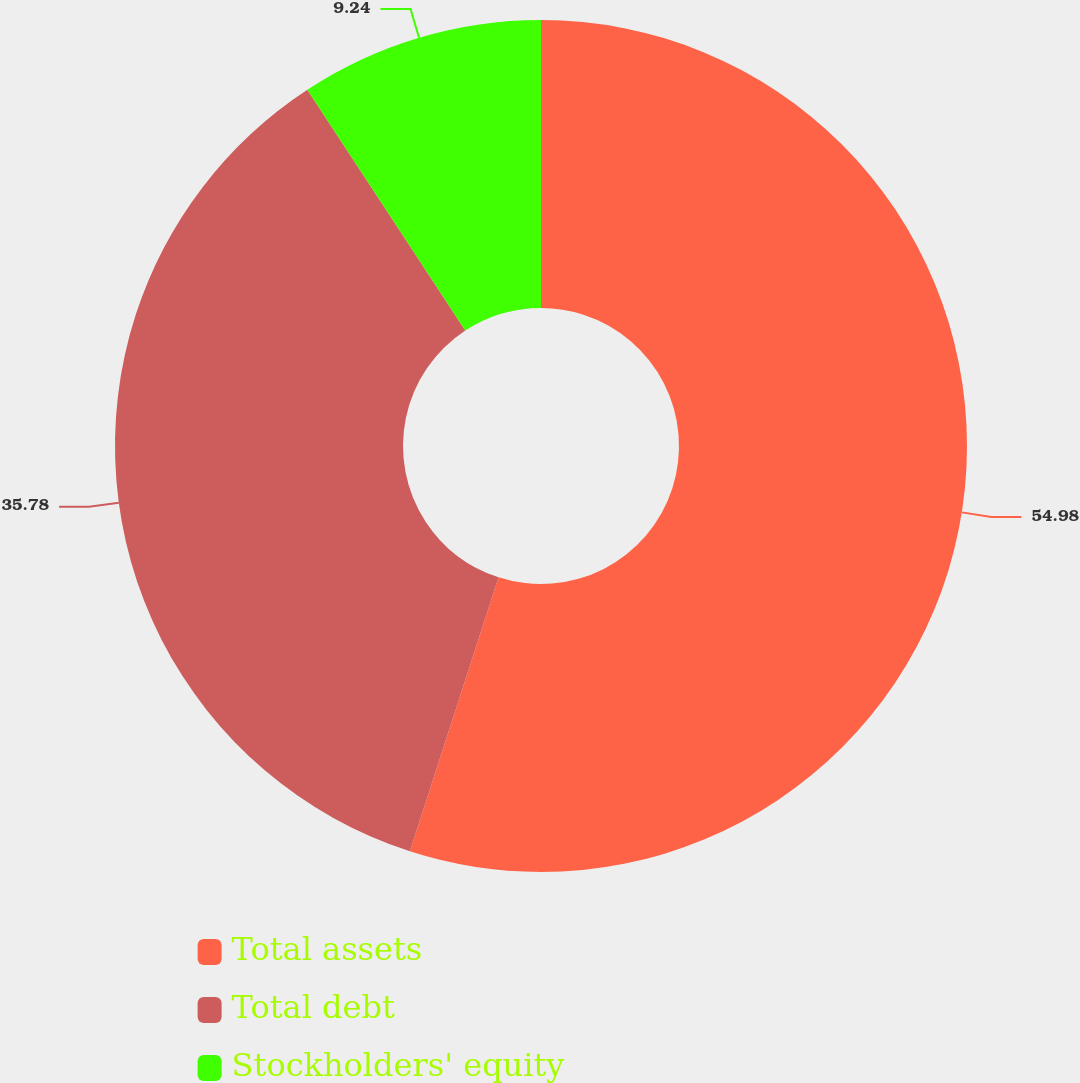Convert chart to OTSL. <chart><loc_0><loc_0><loc_500><loc_500><pie_chart><fcel>Total assets<fcel>Total debt<fcel>Stockholders' equity<nl><fcel>54.98%<fcel>35.78%<fcel>9.24%<nl></chart> 